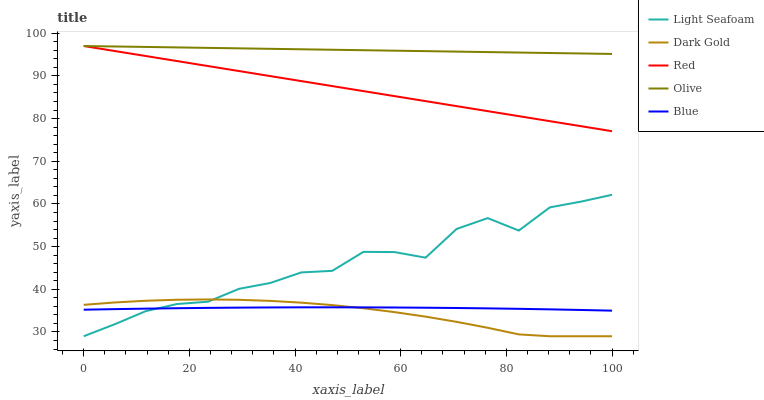Does Dark Gold have the minimum area under the curve?
Answer yes or no. Yes. Does Olive have the maximum area under the curve?
Answer yes or no. Yes. Does Blue have the minimum area under the curve?
Answer yes or no. No. Does Blue have the maximum area under the curve?
Answer yes or no. No. Is Red the smoothest?
Answer yes or no. Yes. Is Light Seafoam the roughest?
Answer yes or no. Yes. Is Blue the smoothest?
Answer yes or no. No. Is Blue the roughest?
Answer yes or no. No. Does Blue have the lowest value?
Answer yes or no. No. Does Light Seafoam have the highest value?
Answer yes or no. No. Is Dark Gold less than Olive?
Answer yes or no. Yes. Is Red greater than Dark Gold?
Answer yes or no. Yes. Does Dark Gold intersect Olive?
Answer yes or no. No. 